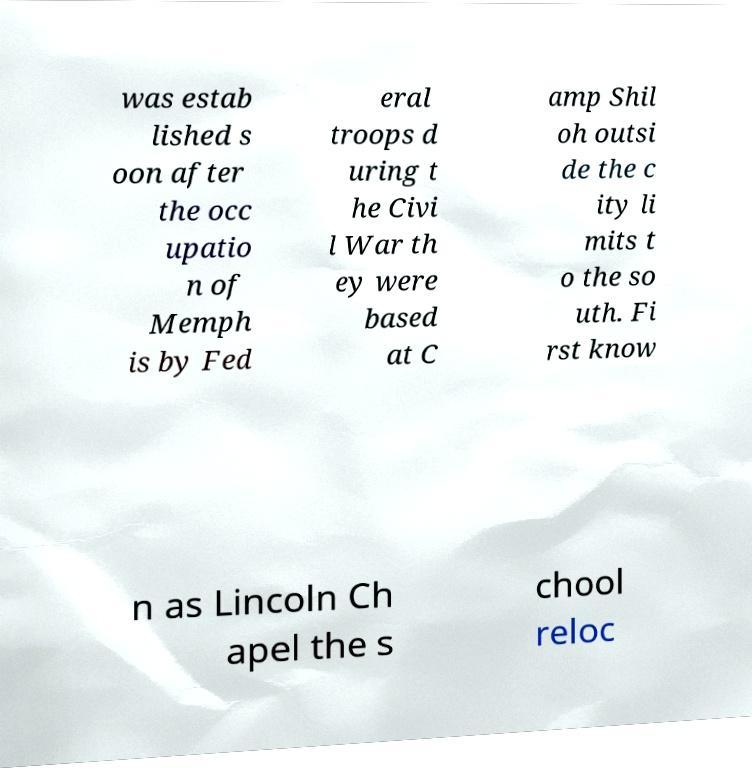Could you assist in decoding the text presented in this image and type it out clearly? was estab lished s oon after the occ upatio n of Memph is by Fed eral troops d uring t he Civi l War th ey were based at C amp Shil oh outsi de the c ity li mits t o the so uth. Fi rst know n as Lincoln Ch apel the s chool reloc 